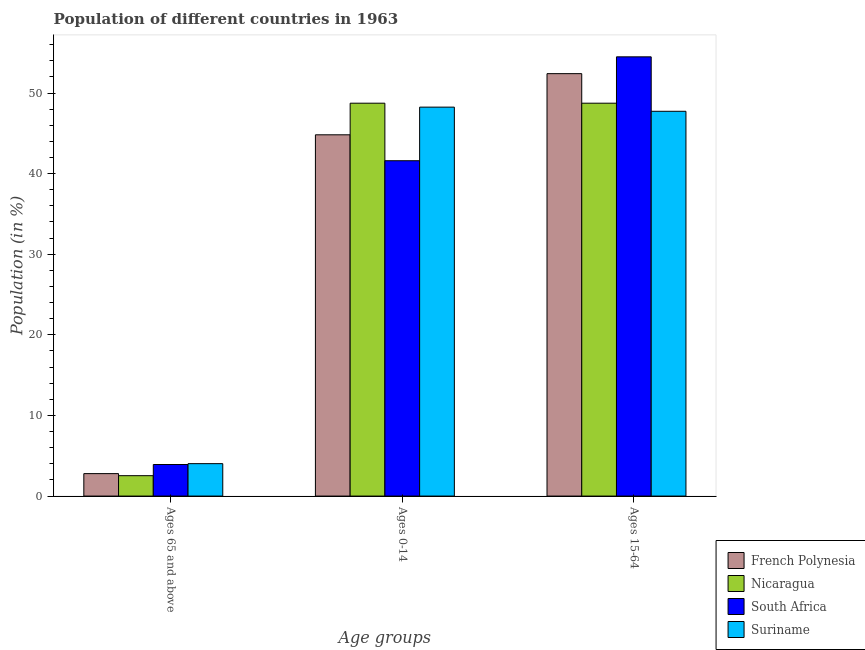How many bars are there on the 1st tick from the right?
Keep it short and to the point. 4. What is the label of the 2nd group of bars from the left?
Your answer should be compact. Ages 0-14. What is the percentage of population within the age-group 15-64 in Nicaragua?
Your response must be concise. 48.74. Across all countries, what is the maximum percentage of population within the age-group of 65 and above?
Offer a terse response. 4.02. Across all countries, what is the minimum percentage of population within the age-group 15-64?
Ensure brevity in your answer.  47.73. In which country was the percentage of population within the age-group 15-64 maximum?
Offer a very short reply. South Africa. In which country was the percentage of population within the age-group 15-64 minimum?
Your answer should be compact. Suriname. What is the total percentage of population within the age-group 0-14 in the graph?
Offer a terse response. 183.4. What is the difference between the percentage of population within the age-group 0-14 in Suriname and that in South Africa?
Keep it short and to the point. 6.65. What is the difference between the percentage of population within the age-group 0-14 in Suriname and the percentage of population within the age-group 15-64 in French Polynesia?
Offer a terse response. -4.15. What is the average percentage of population within the age-group 0-14 per country?
Your answer should be compact. 45.85. What is the difference between the percentage of population within the age-group 15-64 and percentage of population within the age-group 0-14 in French Polynesia?
Keep it short and to the point. 7.59. What is the ratio of the percentage of population within the age-group 0-14 in Nicaragua to that in Suriname?
Give a very brief answer. 1.01. What is the difference between the highest and the second highest percentage of population within the age-group of 65 and above?
Ensure brevity in your answer.  0.11. What is the difference between the highest and the lowest percentage of population within the age-group 0-14?
Keep it short and to the point. 7.14. In how many countries, is the percentage of population within the age-group 0-14 greater than the average percentage of population within the age-group 0-14 taken over all countries?
Your answer should be compact. 2. Is the sum of the percentage of population within the age-group 15-64 in French Polynesia and South Africa greater than the maximum percentage of population within the age-group of 65 and above across all countries?
Your answer should be very brief. Yes. What does the 2nd bar from the left in Ages 65 and above represents?
Your answer should be compact. Nicaragua. What does the 2nd bar from the right in Ages 0-14 represents?
Ensure brevity in your answer.  South Africa. How many bars are there?
Make the answer very short. 12. Are the values on the major ticks of Y-axis written in scientific E-notation?
Give a very brief answer. No. Does the graph contain any zero values?
Your answer should be compact. No. Where does the legend appear in the graph?
Your answer should be very brief. Bottom right. How many legend labels are there?
Provide a short and direct response. 4. What is the title of the graph?
Make the answer very short. Population of different countries in 1963. What is the label or title of the X-axis?
Give a very brief answer. Age groups. What is the Population (in %) of French Polynesia in Ages 65 and above?
Make the answer very short. 2.78. What is the Population (in %) in Nicaragua in Ages 65 and above?
Offer a very short reply. 2.53. What is the Population (in %) of South Africa in Ages 65 and above?
Provide a succinct answer. 3.91. What is the Population (in %) in Suriname in Ages 65 and above?
Keep it short and to the point. 4.02. What is the Population (in %) in French Polynesia in Ages 0-14?
Ensure brevity in your answer.  44.81. What is the Population (in %) in Nicaragua in Ages 0-14?
Your response must be concise. 48.74. What is the Population (in %) of South Africa in Ages 0-14?
Make the answer very short. 41.6. What is the Population (in %) of Suriname in Ages 0-14?
Give a very brief answer. 48.25. What is the Population (in %) of French Polynesia in Ages 15-64?
Provide a succinct answer. 52.4. What is the Population (in %) in Nicaragua in Ages 15-64?
Ensure brevity in your answer.  48.74. What is the Population (in %) in South Africa in Ages 15-64?
Offer a terse response. 54.49. What is the Population (in %) in Suriname in Ages 15-64?
Your response must be concise. 47.73. Across all Age groups, what is the maximum Population (in %) in French Polynesia?
Provide a succinct answer. 52.4. Across all Age groups, what is the maximum Population (in %) of Nicaragua?
Provide a succinct answer. 48.74. Across all Age groups, what is the maximum Population (in %) of South Africa?
Your response must be concise. 54.49. Across all Age groups, what is the maximum Population (in %) of Suriname?
Keep it short and to the point. 48.25. Across all Age groups, what is the minimum Population (in %) in French Polynesia?
Keep it short and to the point. 2.78. Across all Age groups, what is the minimum Population (in %) of Nicaragua?
Offer a terse response. 2.53. Across all Age groups, what is the minimum Population (in %) of South Africa?
Offer a very short reply. 3.91. Across all Age groups, what is the minimum Population (in %) of Suriname?
Your response must be concise. 4.02. What is the total Population (in %) in French Polynesia in the graph?
Make the answer very short. 100. What is the total Population (in %) of Nicaragua in the graph?
Ensure brevity in your answer.  100. What is the total Population (in %) of South Africa in the graph?
Make the answer very short. 100. What is the difference between the Population (in %) of French Polynesia in Ages 65 and above and that in Ages 0-14?
Your answer should be compact. -42.03. What is the difference between the Population (in %) in Nicaragua in Ages 65 and above and that in Ages 0-14?
Offer a terse response. -46.21. What is the difference between the Population (in %) of South Africa in Ages 65 and above and that in Ages 0-14?
Keep it short and to the point. -37.69. What is the difference between the Population (in %) in Suriname in Ages 65 and above and that in Ages 0-14?
Give a very brief answer. -44.23. What is the difference between the Population (in %) in French Polynesia in Ages 65 and above and that in Ages 15-64?
Your answer should be very brief. -49.62. What is the difference between the Population (in %) of Nicaragua in Ages 65 and above and that in Ages 15-64?
Ensure brevity in your answer.  -46.21. What is the difference between the Population (in %) of South Africa in Ages 65 and above and that in Ages 15-64?
Make the answer very short. -50.57. What is the difference between the Population (in %) in Suriname in Ages 65 and above and that in Ages 15-64?
Offer a terse response. -43.71. What is the difference between the Population (in %) in French Polynesia in Ages 0-14 and that in Ages 15-64?
Ensure brevity in your answer.  -7.59. What is the difference between the Population (in %) of Nicaragua in Ages 0-14 and that in Ages 15-64?
Your response must be concise. -0. What is the difference between the Population (in %) of South Africa in Ages 0-14 and that in Ages 15-64?
Give a very brief answer. -12.89. What is the difference between the Population (in %) in Suriname in Ages 0-14 and that in Ages 15-64?
Your response must be concise. 0.52. What is the difference between the Population (in %) in French Polynesia in Ages 65 and above and the Population (in %) in Nicaragua in Ages 0-14?
Your answer should be compact. -45.95. What is the difference between the Population (in %) in French Polynesia in Ages 65 and above and the Population (in %) in South Africa in Ages 0-14?
Ensure brevity in your answer.  -38.81. What is the difference between the Population (in %) of French Polynesia in Ages 65 and above and the Population (in %) of Suriname in Ages 0-14?
Keep it short and to the point. -45.46. What is the difference between the Population (in %) in Nicaragua in Ages 65 and above and the Population (in %) in South Africa in Ages 0-14?
Give a very brief answer. -39.07. What is the difference between the Population (in %) of Nicaragua in Ages 65 and above and the Population (in %) of Suriname in Ages 0-14?
Keep it short and to the point. -45.72. What is the difference between the Population (in %) of South Africa in Ages 65 and above and the Population (in %) of Suriname in Ages 0-14?
Provide a succinct answer. -44.33. What is the difference between the Population (in %) in French Polynesia in Ages 65 and above and the Population (in %) in Nicaragua in Ages 15-64?
Make the answer very short. -45.95. What is the difference between the Population (in %) of French Polynesia in Ages 65 and above and the Population (in %) of South Africa in Ages 15-64?
Your response must be concise. -51.7. What is the difference between the Population (in %) of French Polynesia in Ages 65 and above and the Population (in %) of Suriname in Ages 15-64?
Offer a terse response. -44.95. What is the difference between the Population (in %) of Nicaragua in Ages 65 and above and the Population (in %) of South Africa in Ages 15-64?
Keep it short and to the point. -51.96. What is the difference between the Population (in %) in Nicaragua in Ages 65 and above and the Population (in %) in Suriname in Ages 15-64?
Make the answer very short. -45.2. What is the difference between the Population (in %) of South Africa in Ages 65 and above and the Population (in %) of Suriname in Ages 15-64?
Make the answer very short. -43.82. What is the difference between the Population (in %) of French Polynesia in Ages 0-14 and the Population (in %) of Nicaragua in Ages 15-64?
Give a very brief answer. -3.92. What is the difference between the Population (in %) in French Polynesia in Ages 0-14 and the Population (in %) in South Africa in Ages 15-64?
Offer a terse response. -9.67. What is the difference between the Population (in %) of French Polynesia in Ages 0-14 and the Population (in %) of Suriname in Ages 15-64?
Offer a terse response. -2.92. What is the difference between the Population (in %) in Nicaragua in Ages 0-14 and the Population (in %) in South Africa in Ages 15-64?
Provide a short and direct response. -5.75. What is the difference between the Population (in %) in Nicaragua in Ages 0-14 and the Population (in %) in Suriname in Ages 15-64?
Give a very brief answer. 1. What is the difference between the Population (in %) in South Africa in Ages 0-14 and the Population (in %) in Suriname in Ages 15-64?
Ensure brevity in your answer.  -6.13. What is the average Population (in %) in French Polynesia per Age groups?
Your response must be concise. 33.33. What is the average Population (in %) in Nicaragua per Age groups?
Offer a very short reply. 33.33. What is the average Population (in %) of South Africa per Age groups?
Your answer should be compact. 33.33. What is the average Population (in %) in Suriname per Age groups?
Make the answer very short. 33.33. What is the difference between the Population (in %) of French Polynesia and Population (in %) of Nicaragua in Ages 65 and above?
Make the answer very short. 0.26. What is the difference between the Population (in %) in French Polynesia and Population (in %) in South Africa in Ages 65 and above?
Ensure brevity in your answer.  -1.13. What is the difference between the Population (in %) of French Polynesia and Population (in %) of Suriname in Ages 65 and above?
Offer a terse response. -1.24. What is the difference between the Population (in %) of Nicaragua and Population (in %) of South Africa in Ages 65 and above?
Offer a terse response. -1.39. What is the difference between the Population (in %) in Nicaragua and Population (in %) in Suriname in Ages 65 and above?
Provide a short and direct response. -1.49. What is the difference between the Population (in %) in South Africa and Population (in %) in Suriname in Ages 65 and above?
Make the answer very short. -0.11. What is the difference between the Population (in %) of French Polynesia and Population (in %) of Nicaragua in Ages 0-14?
Offer a very short reply. -3.92. What is the difference between the Population (in %) of French Polynesia and Population (in %) of South Africa in Ages 0-14?
Make the answer very short. 3.21. What is the difference between the Population (in %) of French Polynesia and Population (in %) of Suriname in Ages 0-14?
Make the answer very short. -3.43. What is the difference between the Population (in %) of Nicaragua and Population (in %) of South Africa in Ages 0-14?
Make the answer very short. 7.14. What is the difference between the Population (in %) of Nicaragua and Population (in %) of Suriname in Ages 0-14?
Provide a short and direct response. 0.49. What is the difference between the Population (in %) of South Africa and Population (in %) of Suriname in Ages 0-14?
Offer a terse response. -6.65. What is the difference between the Population (in %) of French Polynesia and Population (in %) of Nicaragua in Ages 15-64?
Your answer should be compact. 3.67. What is the difference between the Population (in %) of French Polynesia and Population (in %) of South Africa in Ages 15-64?
Ensure brevity in your answer.  -2.08. What is the difference between the Population (in %) in French Polynesia and Population (in %) in Suriname in Ages 15-64?
Provide a succinct answer. 4.67. What is the difference between the Population (in %) in Nicaragua and Population (in %) in South Africa in Ages 15-64?
Offer a terse response. -5.75. What is the difference between the Population (in %) of South Africa and Population (in %) of Suriname in Ages 15-64?
Make the answer very short. 6.76. What is the ratio of the Population (in %) in French Polynesia in Ages 65 and above to that in Ages 0-14?
Your answer should be compact. 0.06. What is the ratio of the Population (in %) of Nicaragua in Ages 65 and above to that in Ages 0-14?
Your response must be concise. 0.05. What is the ratio of the Population (in %) of South Africa in Ages 65 and above to that in Ages 0-14?
Make the answer very short. 0.09. What is the ratio of the Population (in %) in Suriname in Ages 65 and above to that in Ages 0-14?
Offer a very short reply. 0.08. What is the ratio of the Population (in %) in French Polynesia in Ages 65 and above to that in Ages 15-64?
Your answer should be compact. 0.05. What is the ratio of the Population (in %) of Nicaragua in Ages 65 and above to that in Ages 15-64?
Offer a very short reply. 0.05. What is the ratio of the Population (in %) of South Africa in Ages 65 and above to that in Ages 15-64?
Ensure brevity in your answer.  0.07. What is the ratio of the Population (in %) of Suriname in Ages 65 and above to that in Ages 15-64?
Your answer should be very brief. 0.08. What is the ratio of the Population (in %) in French Polynesia in Ages 0-14 to that in Ages 15-64?
Give a very brief answer. 0.86. What is the ratio of the Population (in %) in Nicaragua in Ages 0-14 to that in Ages 15-64?
Provide a short and direct response. 1. What is the ratio of the Population (in %) in South Africa in Ages 0-14 to that in Ages 15-64?
Make the answer very short. 0.76. What is the ratio of the Population (in %) of Suriname in Ages 0-14 to that in Ages 15-64?
Provide a short and direct response. 1.01. What is the difference between the highest and the second highest Population (in %) of French Polynesia?
Give a very brief answer. 7.59. What is the difference between the highest and the second highest Population (in %) in Nicaragua?
Make the answer very short. 0. What is the difference between the highest and the second highest Population (in %) in South Africa?
Offer a very short reply. 12.89. What is the difference between the highest and the second highest Population (in %) of Suriname?
Your response must be concise. 0.52. What is the difference between the highest and the lowest Population (in %) of French Polynesia?
Provide a short and direct response. 49.62. What is the difference between the highest and the lowest Population (in %) in Nicaragua?
Ensure brevity in your answer.  46.21. What is the difference between the highest and the lowest Population (in %) of South Africa?
Provide a short and direct response. 50.57. What is the difference between the highest and the lowest Population (in %) in Suriname?
Your response must be concise. 44.23. 